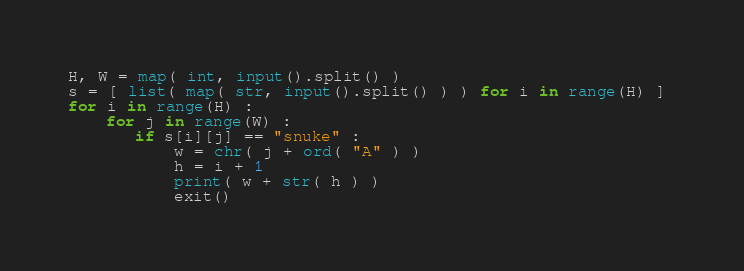Convert code to text. <code><loc_0><loc_0><loc_500><loc_500><_Python_>H, W = map( int, input().split() )
s = [ list( map( str, input().split() ) ) for i in range(H) ] 
for i in range(H) : 
    for j in range(W) : 
       if s[i][j] == "snuke" : 
           w = chr( j + ord( "A" ) )
           h = i + 1
           print( w + str( h ) )
           exit()
</code> 